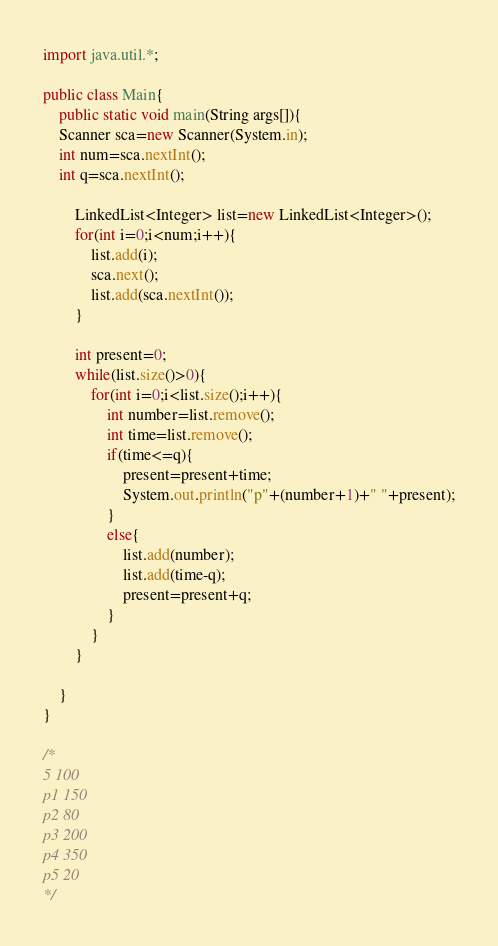Convert code to text. <code><loc_0><loc_0><loc_500><loc_500><_Java_>import java.util.*;

public class Main{
	public static void main(String args[]){
	Scanner sca=new Scanner(System.in);
	int num=sca.nextInt();
	int q=sca.nextInt();
	
		LinkedList<Integer> list=new LinkedList<Integer>();
		for(int i=0;i<num;i++){
			list.add(i);
			sca.next();
			list.add(sca.nextInt());
		}
		
		int present=0;
		while(list.size()>0){
			for(int i=0;i<list.size();i++){
				int number=list.remove();
				int time=list.remove();
				if(time<=q){
					present=present+time;
					System.out.println("p"+(number+1)+" "+present);
				}
				else{
					list.add(number);
					list.add(time-q);
					present=present+q;
				}
			}
		}
	
	}
}

/*
5 100
p1 150
p2 80
p3 200
p4 350
p5 20 
*/



</code> 